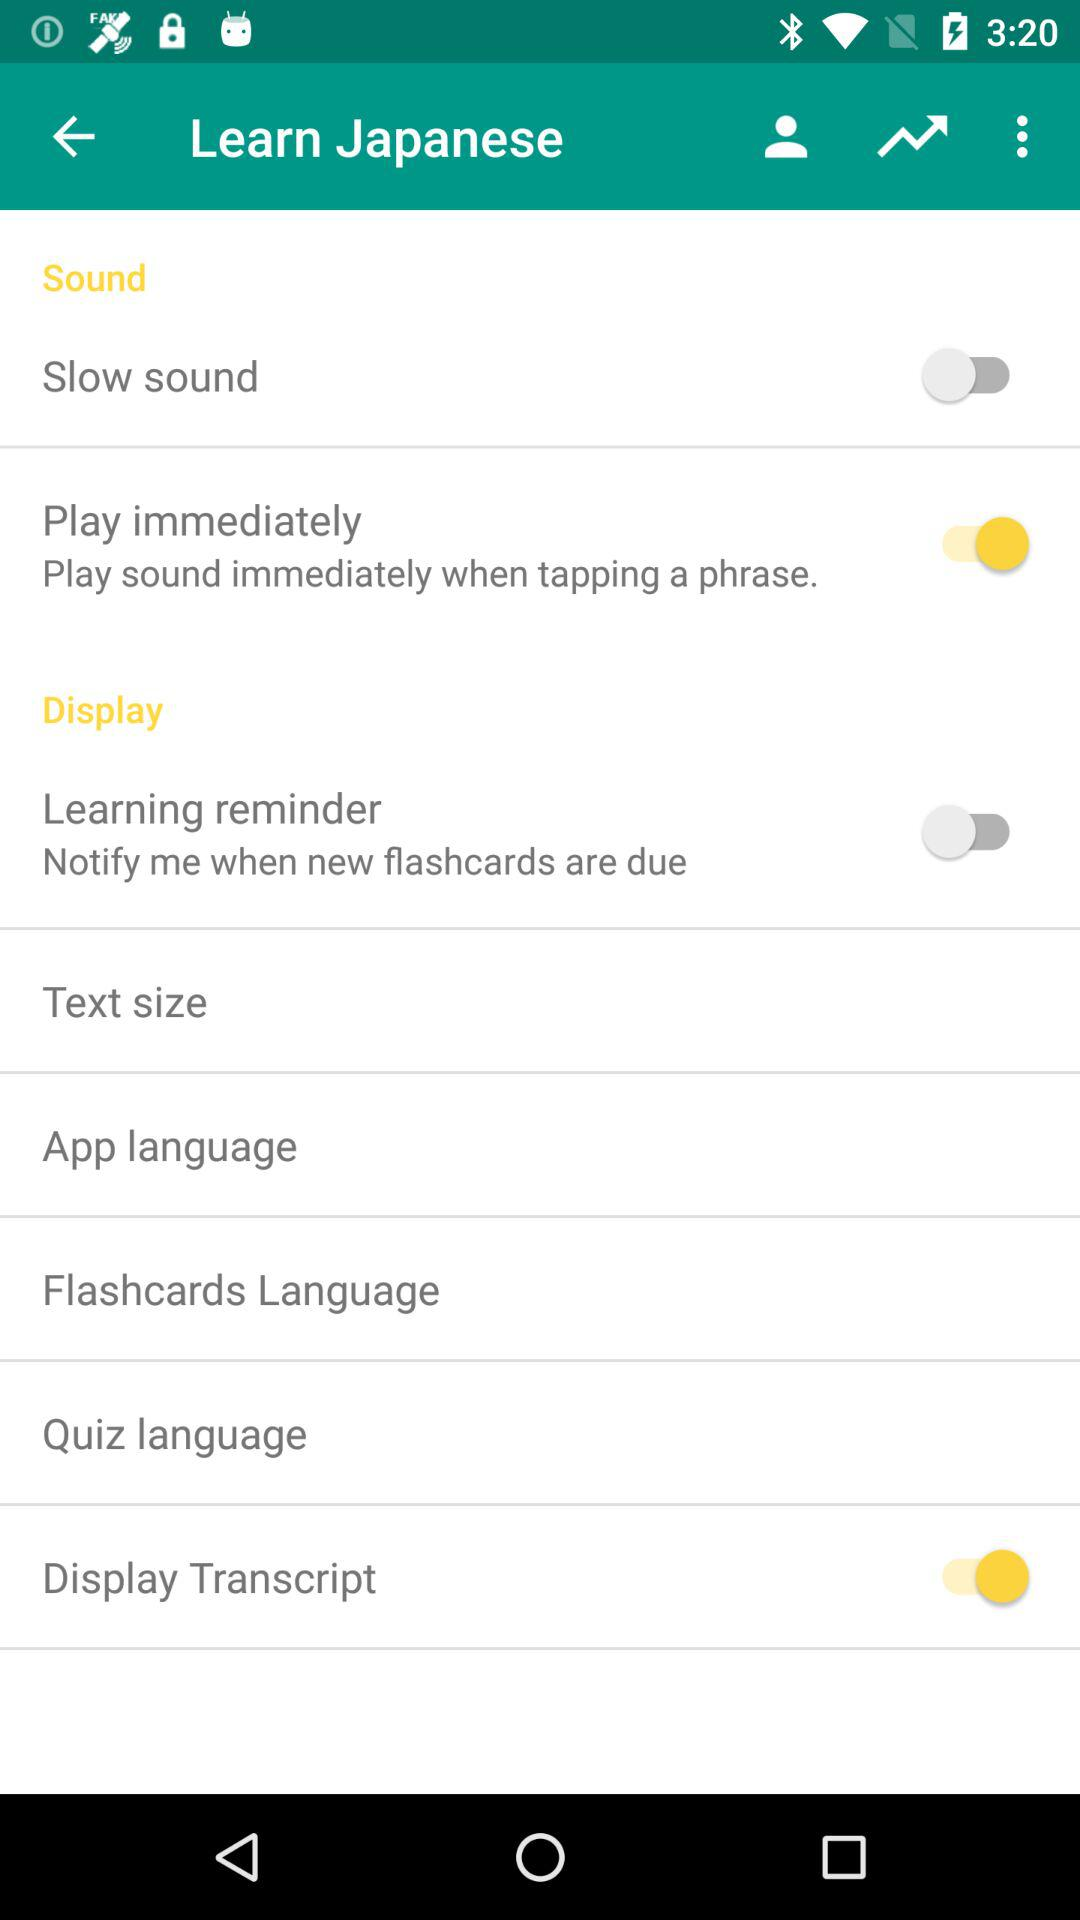What is the current status of the "Play immediately" setting? The current status of the "Play immediately" setting is "on". 